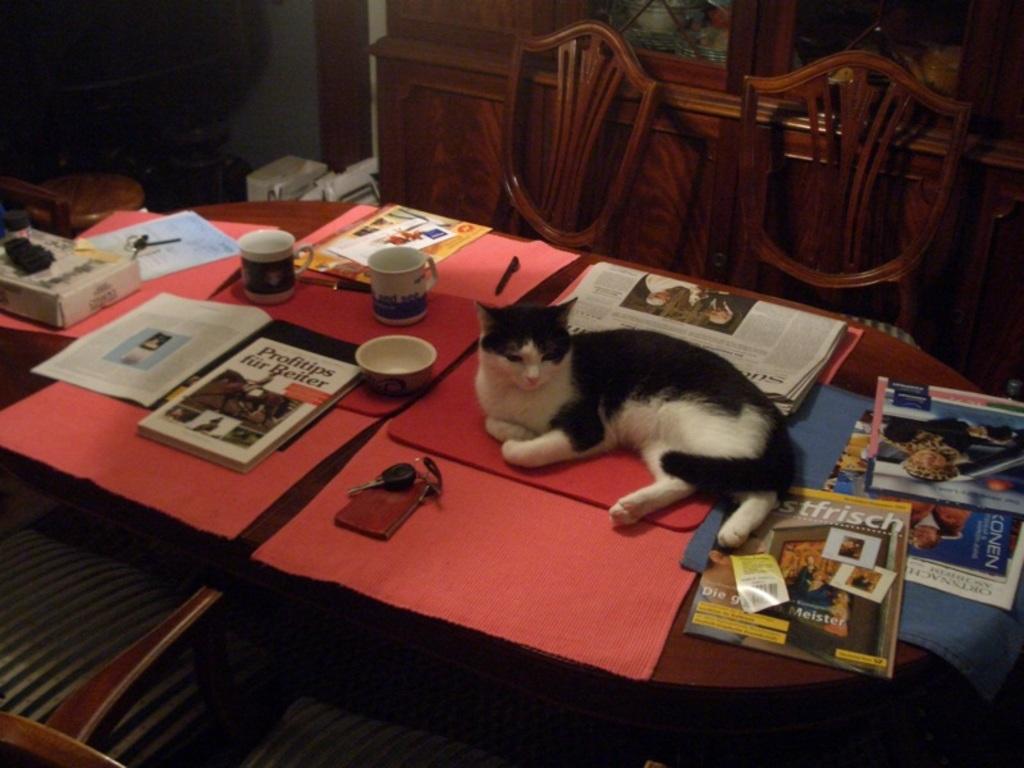Could you give a brief overview of what you see in this image? In this image, There is a table on that table there are some books and there is a newspaper in white color and there are some cups and there is a key on the table, There is a cat sitting on the table which is in black color, In the background there are some chairs which are in brown color and there is a brown color wooden box. 